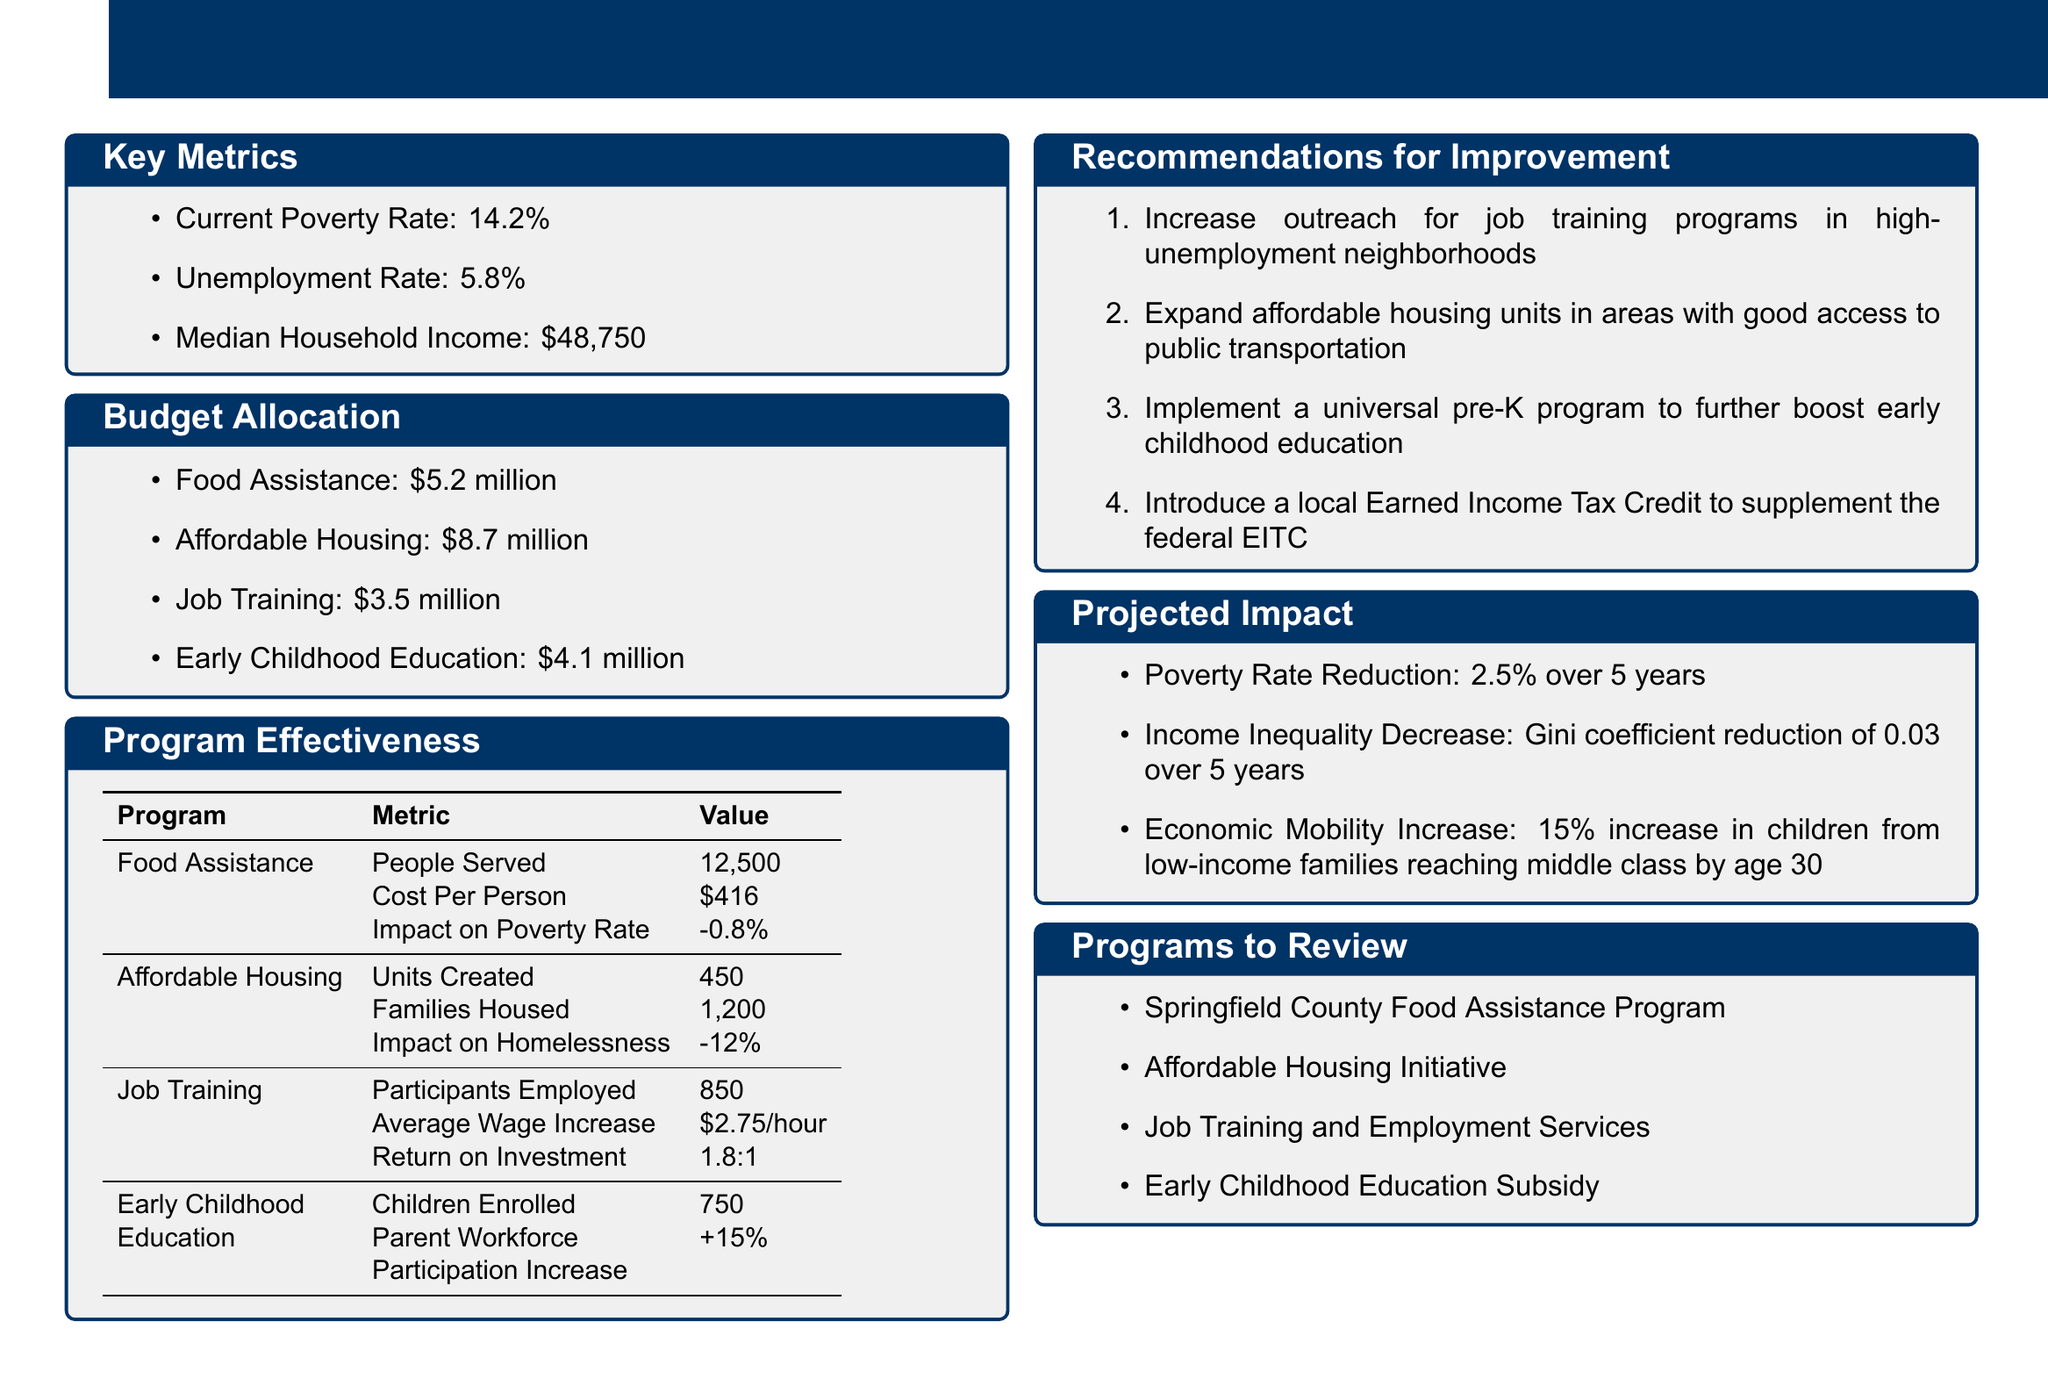What is the current poverty rate? The current poverty rate is provided as a key metric in the document.
Answer: 14.2% How much is allocated to affordable housing? The budget allocation section details the amount set aside for affordable housing programs.
Answer: \$8.7 million What is the impact of food assistance on the poverty rate? The program effectiveness section includes the impact of food assistance on the poverty rate.
Answer: -0.8% How many people are served by the food assistance program? This number is specified in the program effectiveness section for the food assistance program.
Answer: 12,500 What is the average wage increase for job training participants? The average wage increase is listed under the program effectiveness metrics for job training.
Answer: \$2.75/hour What is one recommendation for improving job training programs? The recommendations section provides suggestions for enhancing job training initiatives.
Answer: Increase outreach for job training programs in high-unemployment neighborhoods What is the projected reduction in the poverty rate over five years? The projected impact section estimates the poverty rate reduction over a specified time frame.
Answer: 2.5% Which program has 750 children enrolled? The effectiveness metrics outline this number in relation to the corresponding program.
Answer: Early Childhood Education What is the Gini coefficient reduction projected over five years? This specific metric related to income inequality is mentioned in the projected impact section.
Answer: 0.03 